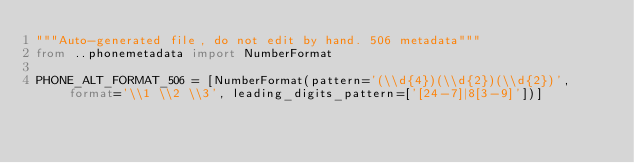Convert code to text. <code><loc_0><loc_0><loc_500><loc_500><_Python_>"""Auto-generated file, do not edit by hand. 506 metadata"""
from ..phonemetadata import NumberFormat

PHONE_ALT_FORMAT_506 = [NumberFormat(pattern='(\\d{4})(\\d{2})(\\d{2})', format='\\1 \\2 \\3', leading_digits_pattern=['[24-7]|8[3-9]'])]
</code> 